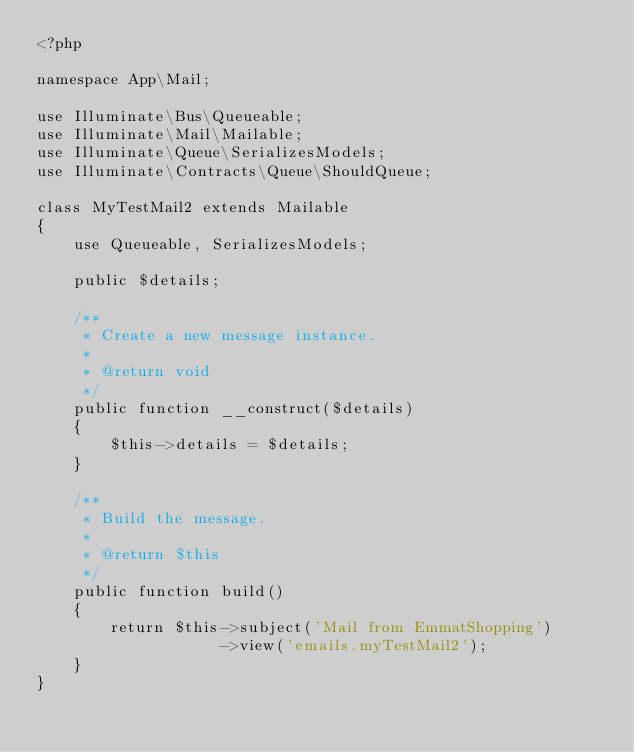<code> <loc_0><loc_0><loc_500><loc_500><_PHP_><?php
  
namespace App\Mail;
   
use Illuminate\Bus\Queueable;
use Illuminate\Mail\Mailable;
use Illuminate\Queue\SerializesModels;
use Illuminate\Contracts\Queue\ShouldQueue;
  
class MyTestMail2 extends Mailable
{
    use Queueable, SerializesModels;
  
    public $details;
   
    /**
     * Create a new message instance.
     *
     * @return void
     */
    public function __construct($details)
    {
        $this->details = $details;
    }
   
    /**
     * Build the message.
     *
     * @return $this
     */
    public function build()
    {
        return $this->subject('Mail from EmmatShopping')
                    ->view('emails.myTestMail2');
    }
}</code> 